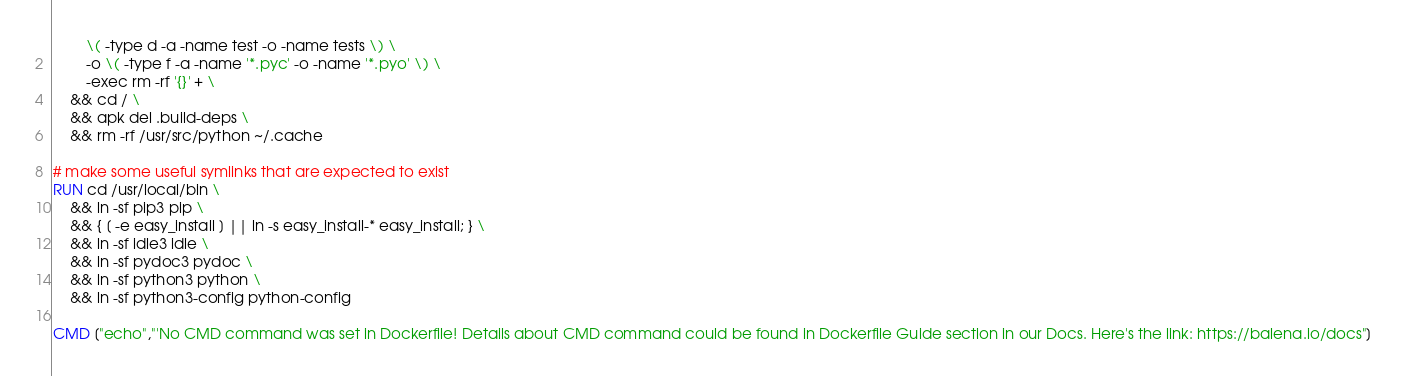Convert code to text. <code><loc_0><loc_0><loc_500><loc_500><_Dockerfile_>		\( -type d -a -name test -o -name tests \) \
		-o \( -type f -a -name '*.pyc' -o -name '*.pyo' \) \
		-exec rm -rf '{}' + \
	&& cd / \
	&& apk del .build-deps \
	&& rm -rf /usr/src/python ~/.cache

# make some useful symlinks that are expected to exist
RUN cd /usr/local/bin \
	&& ln -sf pip3 pip \
	&& { [ -e easy_install ] || ln -s easy_install-* easy_install; } \
	&& ln -sf idle3 idle \
	&& ln -sf pydoc3 pydoc \
	&& ln -sf python3 python \
	&& ln -sf python3-config python-config

CMD ["echo","'No CMD command was set in Dockerfile! Details about CMD command could be found in Dockerfile Guide section in our Docs. Here's the link: https://balena.io/docs"]</code> 